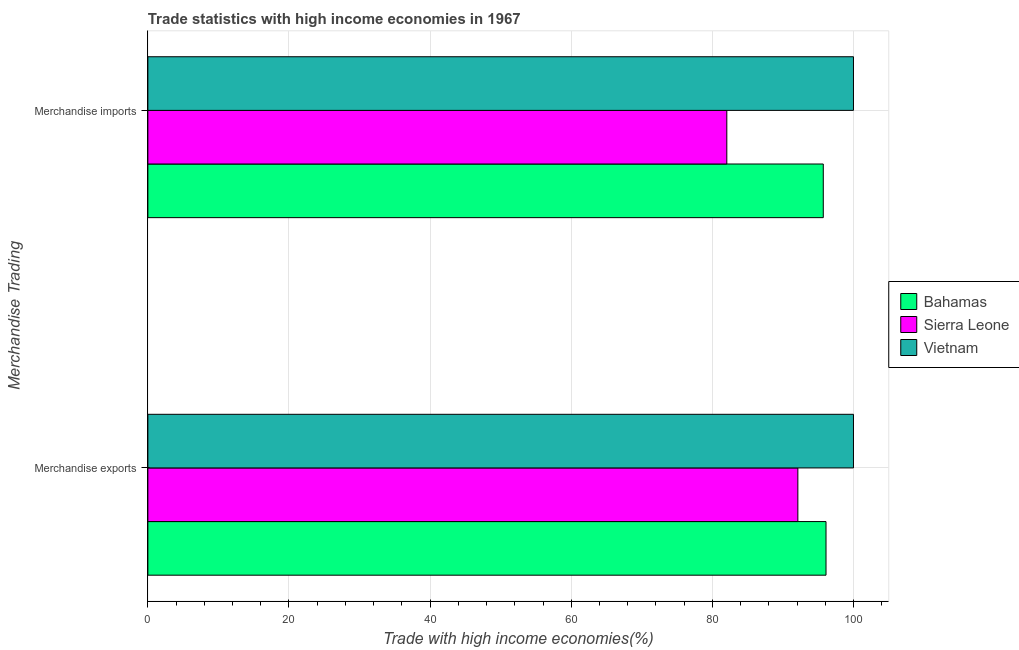How many different coloured bars are there?
Your answer should be very brief. 3. How many groups of bars are there?
Your answer should be compact. 2. Are the number of bars per tick equal to the number of legend labels?
Your answer should be very brief. Yes. Are the number of bars on each tick of the Y-axis equal?
Keep it short and to the point. Yes. How many bars are there on the 1st tick from the top?
Your answer should be very brief. 3. How many bars are there on the 2nd tick from the bottom?
Your response must be concise. 3. What is the merchandise exports in Bahamas?
Your response must be concise. 96.11. Across all countries, what is the maximum merchandise imports?
Offer a very short reply. 100. Across all countries, what is the minimum merchandise exports?
Give a very brief answer. 92.12. In which country was the merchandise imports maximum?
Your answer should be compact. Vietnam. In which country was the merchandise imports minimum?
Offer a terse response. Sierra Leone. What is the total merchandise exports in the graph?
Your response must be concise. 288.23. What is the difference between the merchandise imports in Vietnam and that in Sierra Leone?
Offer a very short reply. 17.95. What is the difference between the merchandise exports in Bahamas and the merchandise imports in Vietnam?
Offer a terse response. -3.89. What is the average merchandise imports per country?
Ensure brevity in your answer.  92.59. What is the difference between the merchandise imports and merchandise exports in Sierra Leone?
Provide a short and direct response. -10.07. What is the ratio of the merchandise imports in Sierra Leone to that in Bahamas?
Provide a succinct answer. 0.86. What does the 2nd bar from the top in Merchandise exports represents?
Provide a succinct answer. Sierra Leone. What does the 2nd bar from the bottom in Merchandise exports represents?
Keep it short and to the point. Sierra Leone. How many bars are there?
Offer a terse response. 6. Are the values on the major ticks of X-axis written in scientific E-notation?
Provide a short and direct response. No. Does the graph contain any zero values?
Keep it short and to the point. No. Does the graph contain grids?
Your answer should be compact. Yes. How many legend labels are there?
Provide a short and direct response. 3. What is the title of the graph?
Give a very brief answer. Trade statistics with high income economies in 1967. Does "Bhutan" appear as one of the legend labels in the graph?
Your answer should be very brief. No. What is the label or title of the X-axis?
Make the answer very short. Trade with high income economies(%). What is the label or title of the Y-axis?
Make the answer very short. Merchandise Trading. What is the Trade with high income economies(%) of Bahamas in Merchandise exports?
Give a very brief answer. 96.11. What is the Trade with high income economies(%) in Sierra Leone in Merchandise exports?
Keep it short and to the point. 92.12. What is the Trade with high income economies(%) in Vietnam in Merchandise exports?
Your response must be concise. 100. What is the Trade with high income economies(%) in Bahamas in Merchandise imports?
Your answer should be compact. 95.72. What is the Trade with high income economies(%) in Sierra Leone in Merchandise imports?
Offer a terse response. 82.05. Across all Merchandise Trading, what is the maximum Trade with high income economies(%) of Bahamas?
Offer a very short reply. 96.11. Across all Merchandise Trading, what is the maximum Trade with high income economies(%) of Sierra Leone?
Your response must be concise. 92.12. Across all Merchandise Trading, what is the maximum Trade with high income economies(%) in Vietnam?
Your answer should be compact. 100. Across all Merchandise Trading, what is the minimum Trade with high income economies(%) of Bahamas?
Your answer should be compact. 95.72. Across all Merchandise Trading, what is the minimum Trade with high income economies(%) in Sierra Leone?
Give a very brief answer. 82.05. What is the total Trade with high income economies(%) of Bahamas in the graph?
Your response must be concise. 191.83. What is the total Trade with high income economies(%) in Sierra Leone in the graph?
Provide a short and direct response. 174.17. What is the total Trade with high income economies(%) of Vietnam in the graph?
Your answer should be compact. 200. What is the difference between the Trade with high income economies(%) in Bahamas in Merchandise exports and that in Merchandise imports?
Make the answer very short. 0.39. What is the difference between the Trade with high income economies(%) in Sierra Leone in Merchandise exports and that in Merchandise imports?
Your answer should be very brief. 10.07. What is the difference between the Trade with high income economies(%) in Vietnam in Merchandise exports and that in Merchandise imports?
Offer a terse response. 0. What is the difference between the Trade with high income economies(%) of Bahamas in Merchandise exports and the Trade with high income economies(%) of Sierra Leone in Merchandise imports?
Ensure brevity in your answer.  14.06. What is the difference between the Trade with high income economies(%) in Bahamas in Merchandise exports and the Trade with high income economies(%) in Vietnam in Merchandise imports?
Offer a terse response. -3.89. What is the difference between the Trade with high income economies(%) in Sierra Leone in Merchandise exports and the Trade with high income economies(%) in Vietnam in Merchandise imports?
Keep it short and to the point. -7.88. What is the average Trade with high income economies(%) of Bahamas per Merchandise Trading?
Your answer should be very brief. 95.92. What is the average Trade with high income economies(%) in Sierra Leone per Merchandise Trading?
Ensure brevity in your answer.  87.09. What is the average Trade with high income economies(%) of Vietnam per Merchandise Trading?
Your response must be concise. 100. What is the difference between the Trade with high income economies(%) of Bahamas and Trade with high income economies(%) of Sierra Leone in Merchandise exports?
Your answer should be compact. 3.99. What is the difference between the Trade with high income economies(%) in Bahamas and Trade with high income economies(%) in Vietnam in Merchandise exports?
Offer a very short reply. -3.89. What is the difference between the Trade with high income economies(%) of Sierra Leone and Trade with high income economies(%) of Vietnam in Merchandise exports?
Make the answer very short. -7.88. What is the difference between the Trade with high income economies(%) of Bahamas and Trade with high income economies(%) of Sierra Leone in Merchandise imports?
Ensure brevity in your answer.  13.67. What is the difference between the Trade with high income economies(%) in Bahamas and Trade with high income economies(%) in Vietnam in Merchandise imports?
Keep it short and to the point. -4.28. What is the difference between the Trade with high income economies(%) in Sierra Leone and Trade with high income economies(%) in Vietnam in Merchandise imports?
Your response must be concise. -17.95. What is the ratio of the Trade with high income economies(%) of Sierra Leone in Merchandise exports to that in Merchandise imports?
Provide a succinct answer. 1.12. What is the difference between the highest and the second highest Trade with high income economies(%) of Bahamas?
Make the answer very short. 0.39. What is the difference between the highest and the second highest Trade with high income economies(%) in Sierra Leone?
Offer a very short reply. 10.07. What is the difference between the highest and the lowest Trade with high income economies(%) in Bahamas?
Provide a short and direct response. 0.39. What is the difference between the highest and the lowest Trade with high income economies(%) in Sierra Leone?
Provide a short and direct response. 10.07. What is the difference between the highest and the lowest Trade with high income economies(%) in Vietnam?
Provide a succinct answer. 0. 